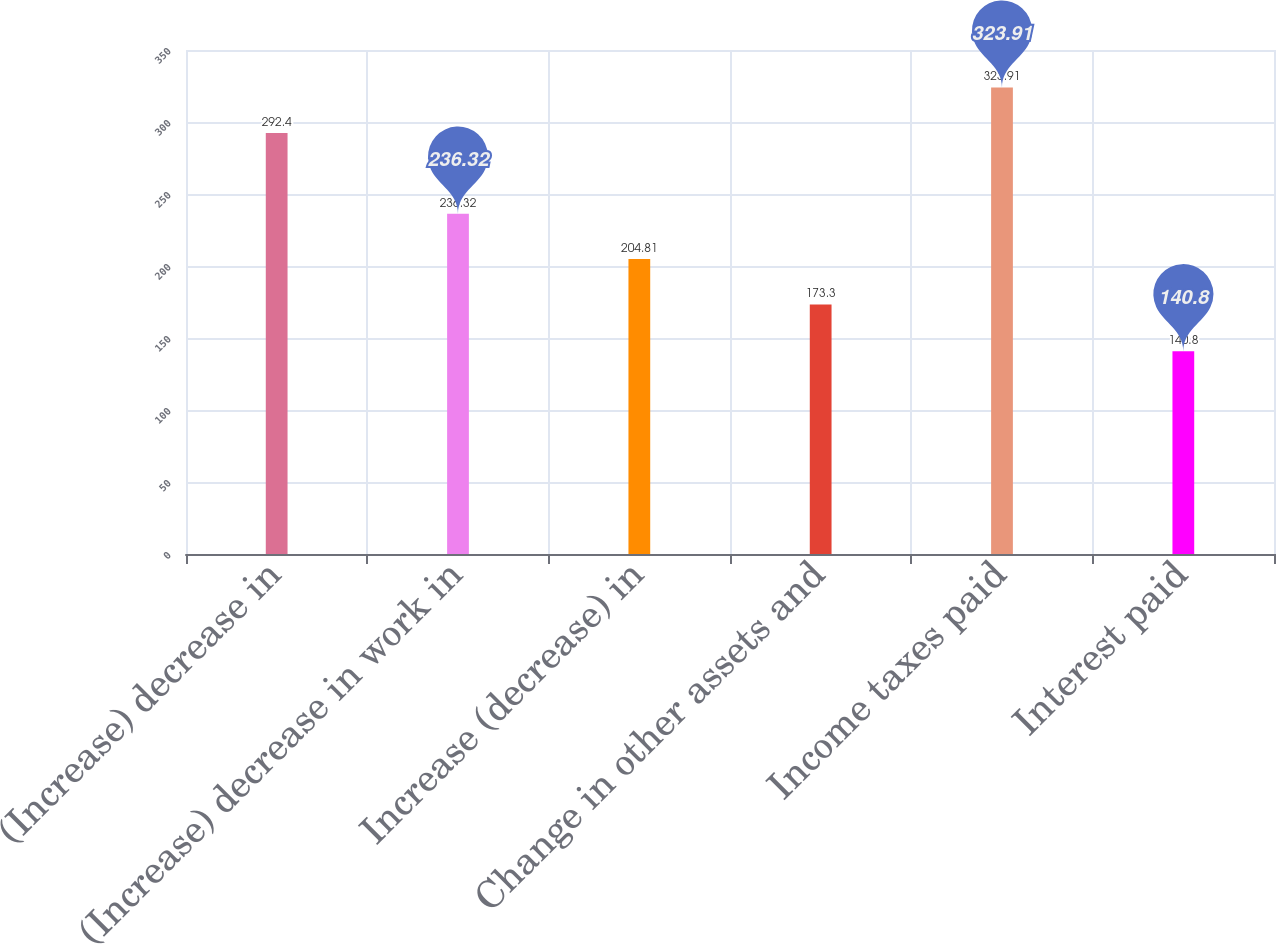Convert chart. <chart><loc_0><loc_0><loc_500><loc_500><bar_chart><fcel>(Increase) decrease in<fcel>(Increase) decrease in work in<fcel>Increase (decrease) in<fcel>Change in other assets and<fcel>Income taxes paid<fcel>Interest paid<nl><fcel>292.4<fcel>236.32<fcel>204.81<fcel>173.3<fcel>323.91<fcel>140.8<nl></chart> 